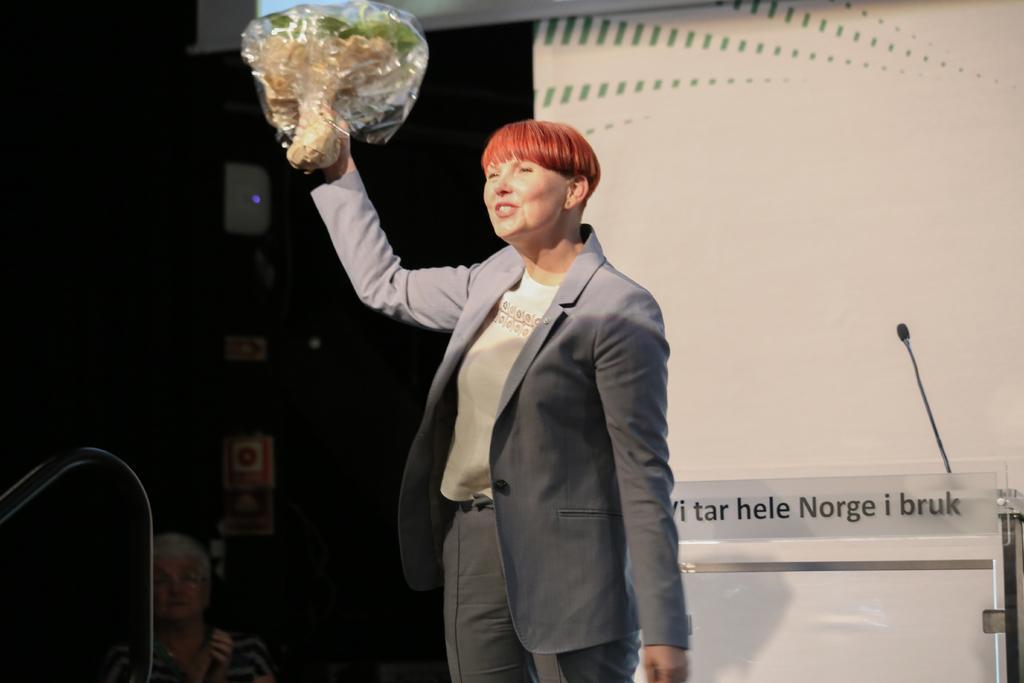In one or two sentences, can you explain what this image depicts? In this image we can see a woman is standing and holding a bouquet in her hand. In the background we can see a person, board, text written on a paper on the glass board, micro phone, rod and other objects. 